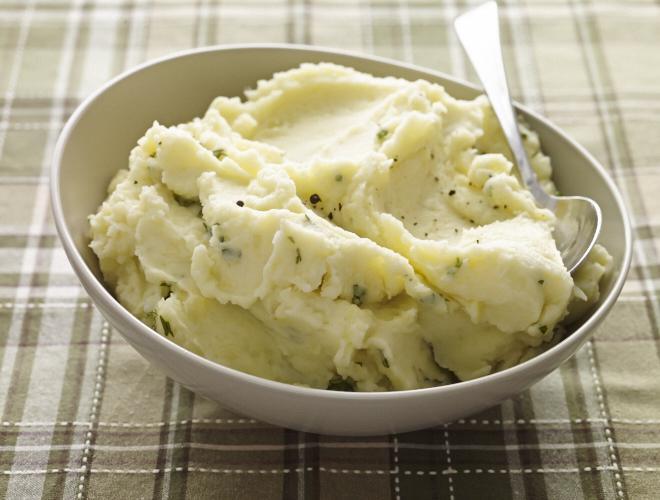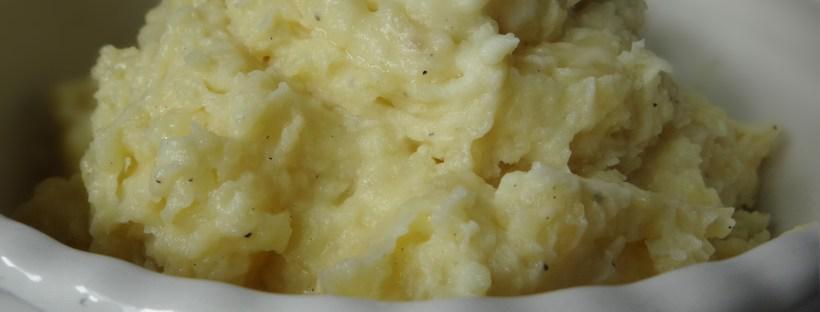The first image is the image on the left, the second image is the image on the right. For the images shown, is this caption "The food in the image on the left is in a white round bowl." true? Answer yes or no. Yes. The first image is the image on the left, the second image is the image on the right. Evaluate the accuracy of this statement regarding the images: "Each image shows mashed potatoes served - without gravy or other menu items - in a round white bowl.". Is it true? Answer yes or no. Yes. 